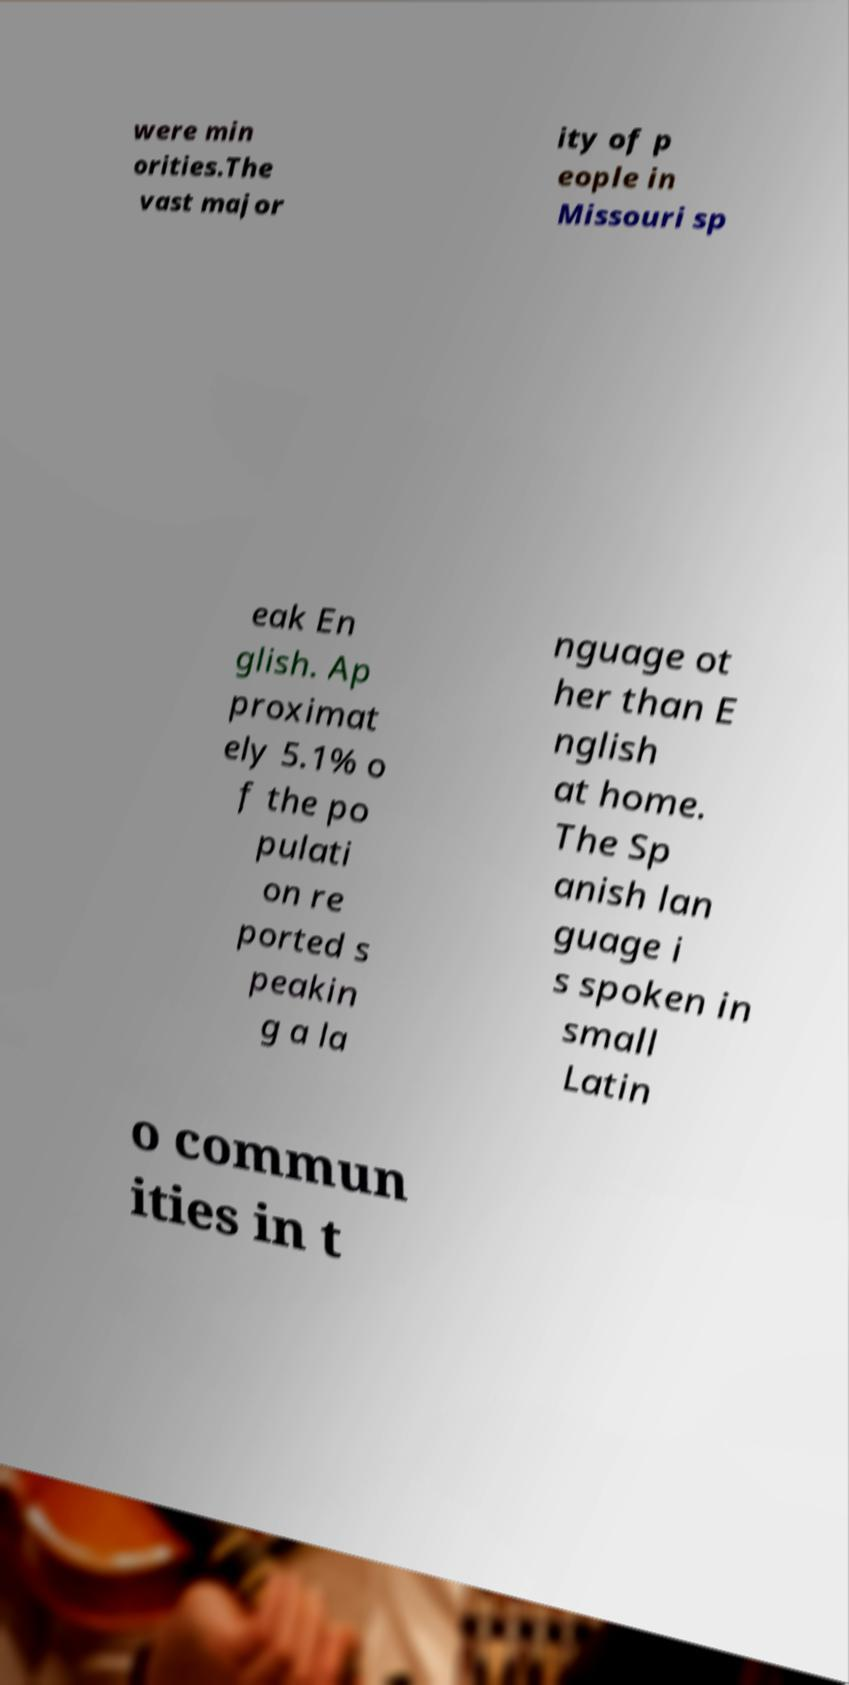For documentation purposes, I need the text within this image transcribed. Could you provide that? were min orities.The vast major ity of p eople in Missouri sp eak En glish. Ap proximat ely 5.1% o f the po pulati on re ported s peakin g a la nguage ot her than E nglish at home. The Sp anish lan guage i s spoken in small Latin o commun ities in t 